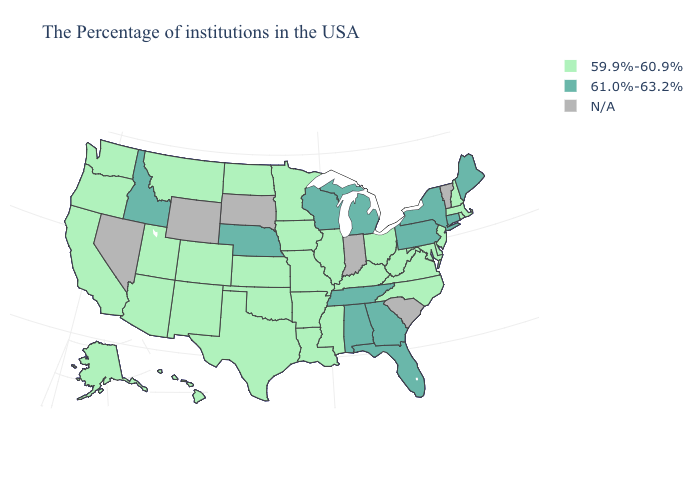What is the value of Iowa?
Quick response, please. 59.9%-60.9%. What is the value of Missouri?
Answer briefly. 59.9%-60.9%. What is the highest value in the MidWest ?
Write a very short answer. 61.0%-63.2%. What is the highest value in the USA?
Give a very brief answer. 61.0%-63.2%. What is the highest value in the Northeast ?
Be succinct. 61.0%-63.2%. Name the states that have a value in the range 61.0%-63.2%?
Quick response, please. Maine, Connecticut, New York, Pennsylvania, Florida, Georgia, Michigan, Alabama, Tennessee, Wisconsin, Nebraska, Idaho. Does Illinois have the lowest value in the MidWest?
Answer briefly. Yes. What is the lowest value in the USA?
Write a very short answer. 59.9%-60.9%. What is the highest value in the MidWest ?
Answer briefly. 61.0%-63.2%. What is the highest value in states that border California?
Give a very brief answer. 59.9%-60.9%. Among the states that border Arizona , which have the highest value?
Be succinct. Colorado, New Mexico, Utah, California. What is the lowest value in the MidWest?
Write a very short answer. 59.9%-60.9%. Name the states that have a value in the range 59.9%-60.9%?
Write a very short answer. Massachusetts, Rhode Island, New Hampshire, New Jersey, Delaware, Maryland, Virginia, North Carolina, West Virginia, Ohio, Kentucky, Illinois, Mississippi, Louisiana, Missouri, Arkansas, Minnesota, Iowa, Kansas, Oklahoma, Texas, North Dakota, Colorado, New Mexico, Utah, Montana, Arizona, California, Washington, Oregon, Alaska, Hawaii. 